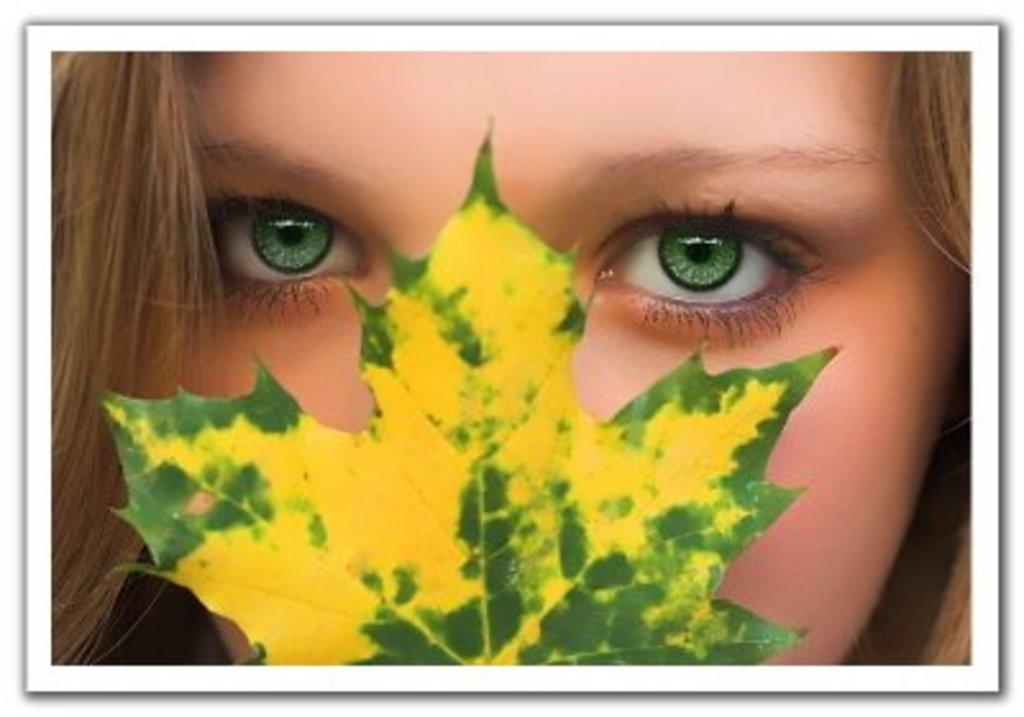What is present in the image? There is a person and a leaf in the image. Can you describe the person in the image? The provided facts do not give any details about the person's appearance or clothing. What is the leaf's condition or color? The provided facts do not give any details about the leaf's condition or color. How many clovers are present in the image? There is no mention of clovers in the provided facts, so it cannot be determined if any are present in the image. What is the flight path of the person in the image? The provided facts do not give any details about the person's actions or movements, so it cannot be determined if they are flying or if there is a flight path. 